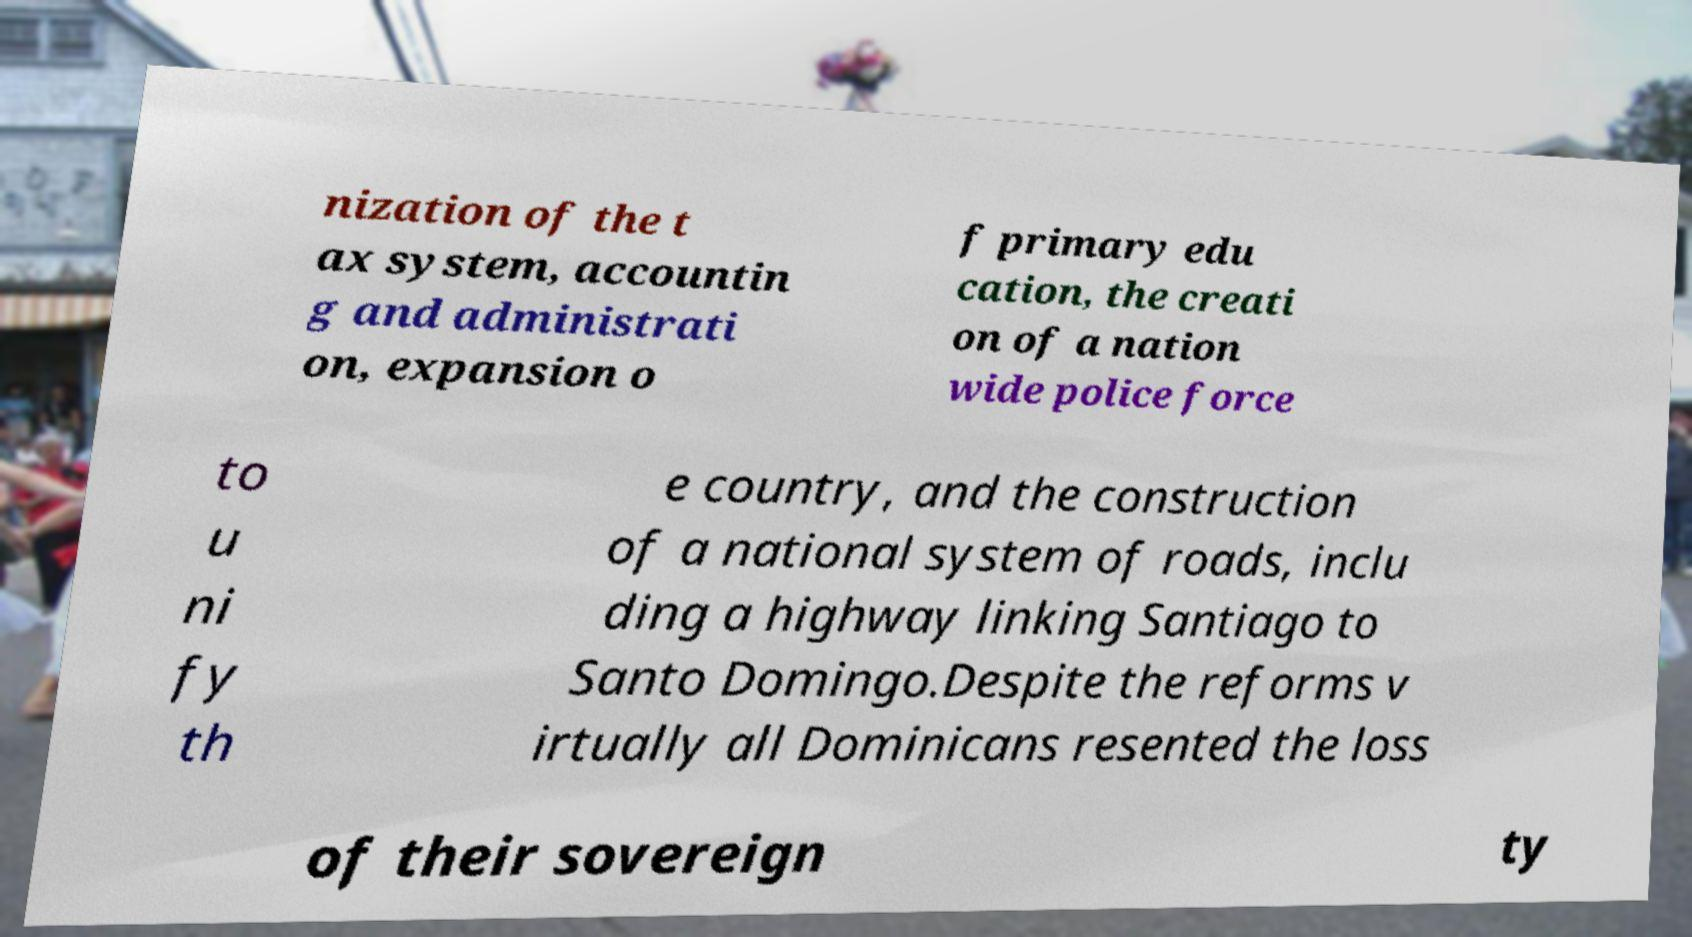Please identify and transcribe the text found in this image. nization of the t ax system, accountin g and administrati on, expansion o f primary edu cation, the creati on of a nation wide police force to u ni fy th e country, and the construction of a national system of roads, inclu ding a highway linking Santiago to Santo Domingo.Despite the reforms v irtually all Dominicans resented the loss of their sovereign ty 